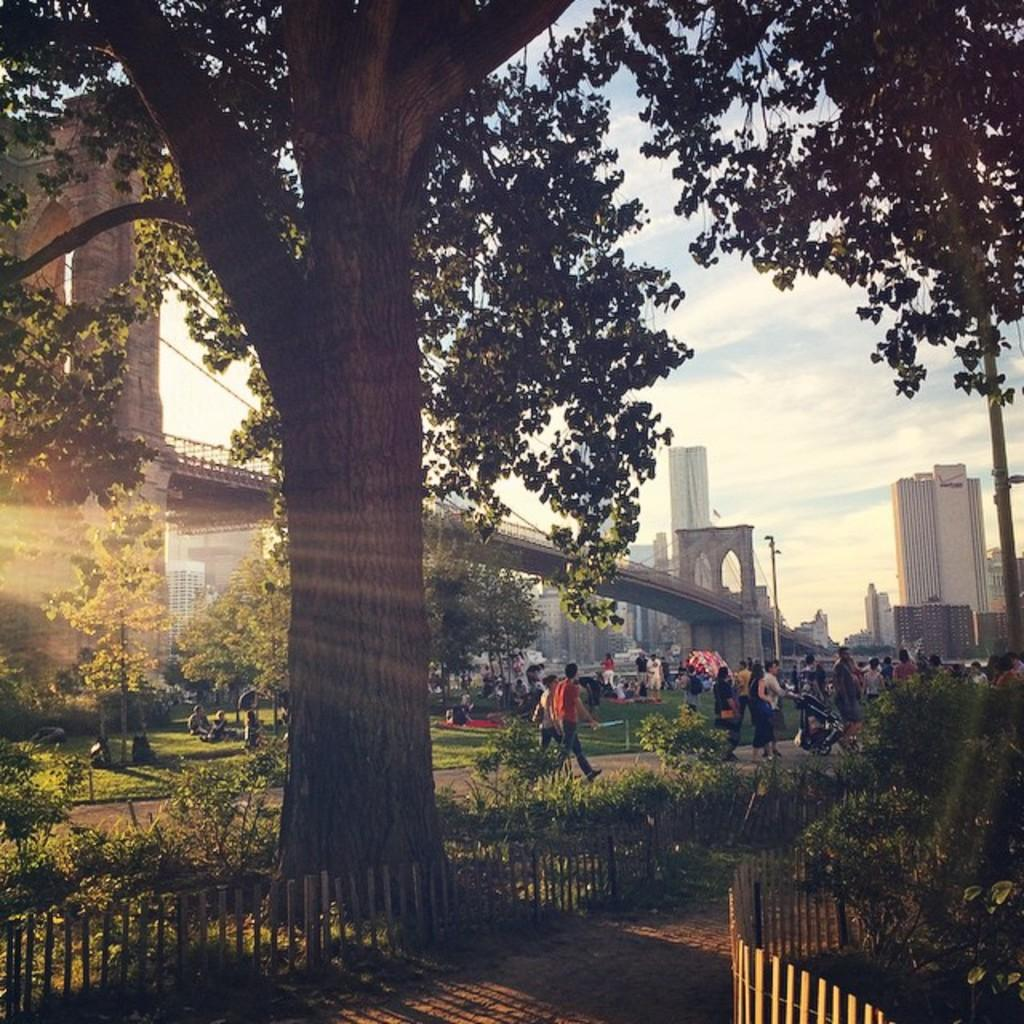How many people are in the image? There are persons in the image, but the exact number is not specified. What can be seen in the image besides the persons? There is a fence, plants, trees, grass, poles, a bridge, buildings, and the sky visible in the image. What type of vegetation is present in the image? There are plants and trees in the image. What architectural feature is present in the image? There is a bridge in the image. What is visible in the background of the image? The sky is visible in the background of the image. What type of chin can be seen on the person in the image? There is no chin visible in the image, as the facts do not mention any specific person or their facial features. How many snakes are slithering on the bridge in the image? There are no snakes present in the image; it features a bridge, but no snakes are mentioned or visible. 